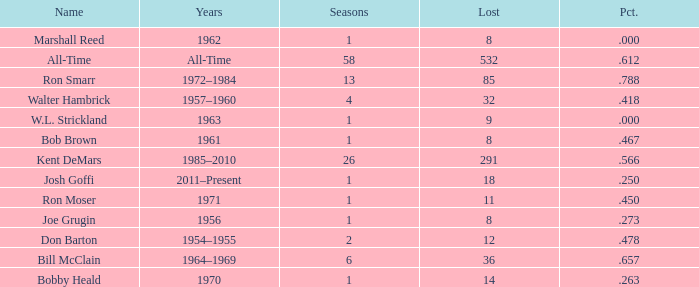Which Seasons has a Name of joe grugin, and a Lost larger than 8? 0.0. 